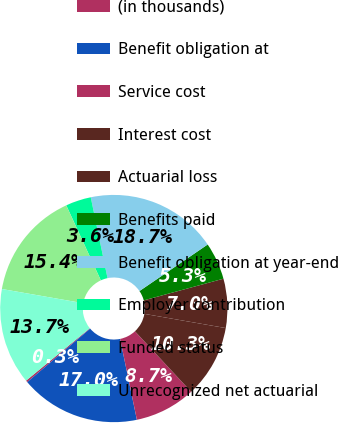<chart> <loc_0><loc_0><loc_500><loc_500><pie_chart><fcel>(in thousands)<fcel>Benefit obligation at<fcel>Service cost<fcel>Interest cost<fcel>Actuarial loss<fcel>Benefits paid<fcel>Benefit obligation at year-end<fcel>Employer contribution<fcel>Funded status<fcel>Unrecognized net actuarial<nl><fcel>0.26%<fcel>17.05%<fcel>8.66%<fcel>10.34%<fcel>6.98%<fcel>5.3%<fcel>18.73%<fcel>3.62%<fcel>15.38%<fcel>13.7%<nl></chart> 